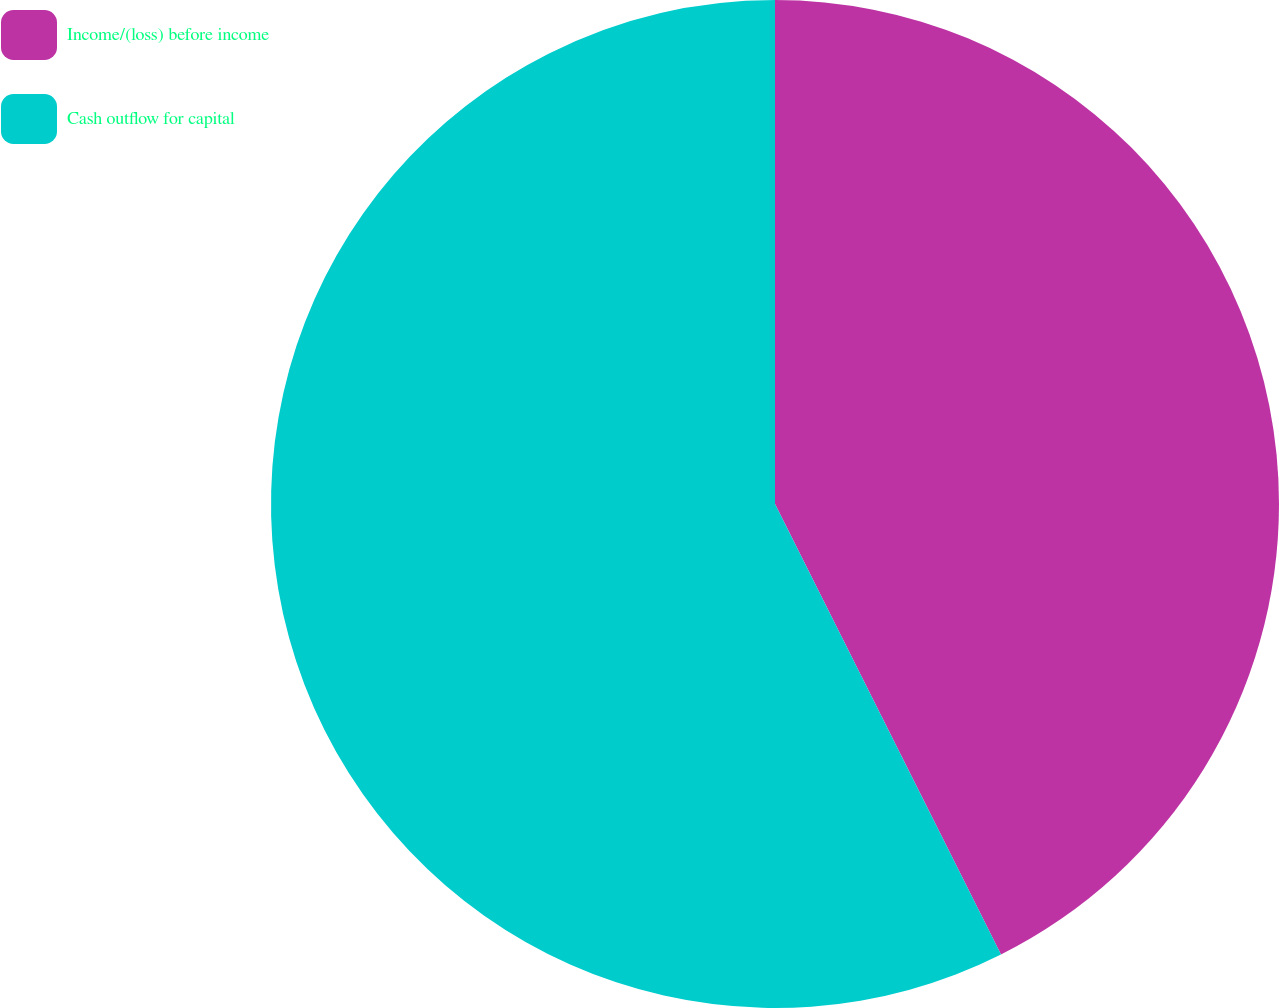Convert chart. <chart><loc_0><loc_0><loc_500><loc_500><pie_chart><fcel>Income/(loss) before income<fcel>Cash outflow for capital<nl><fcel>42.6%<fcel>57.4%<nl></chart> 